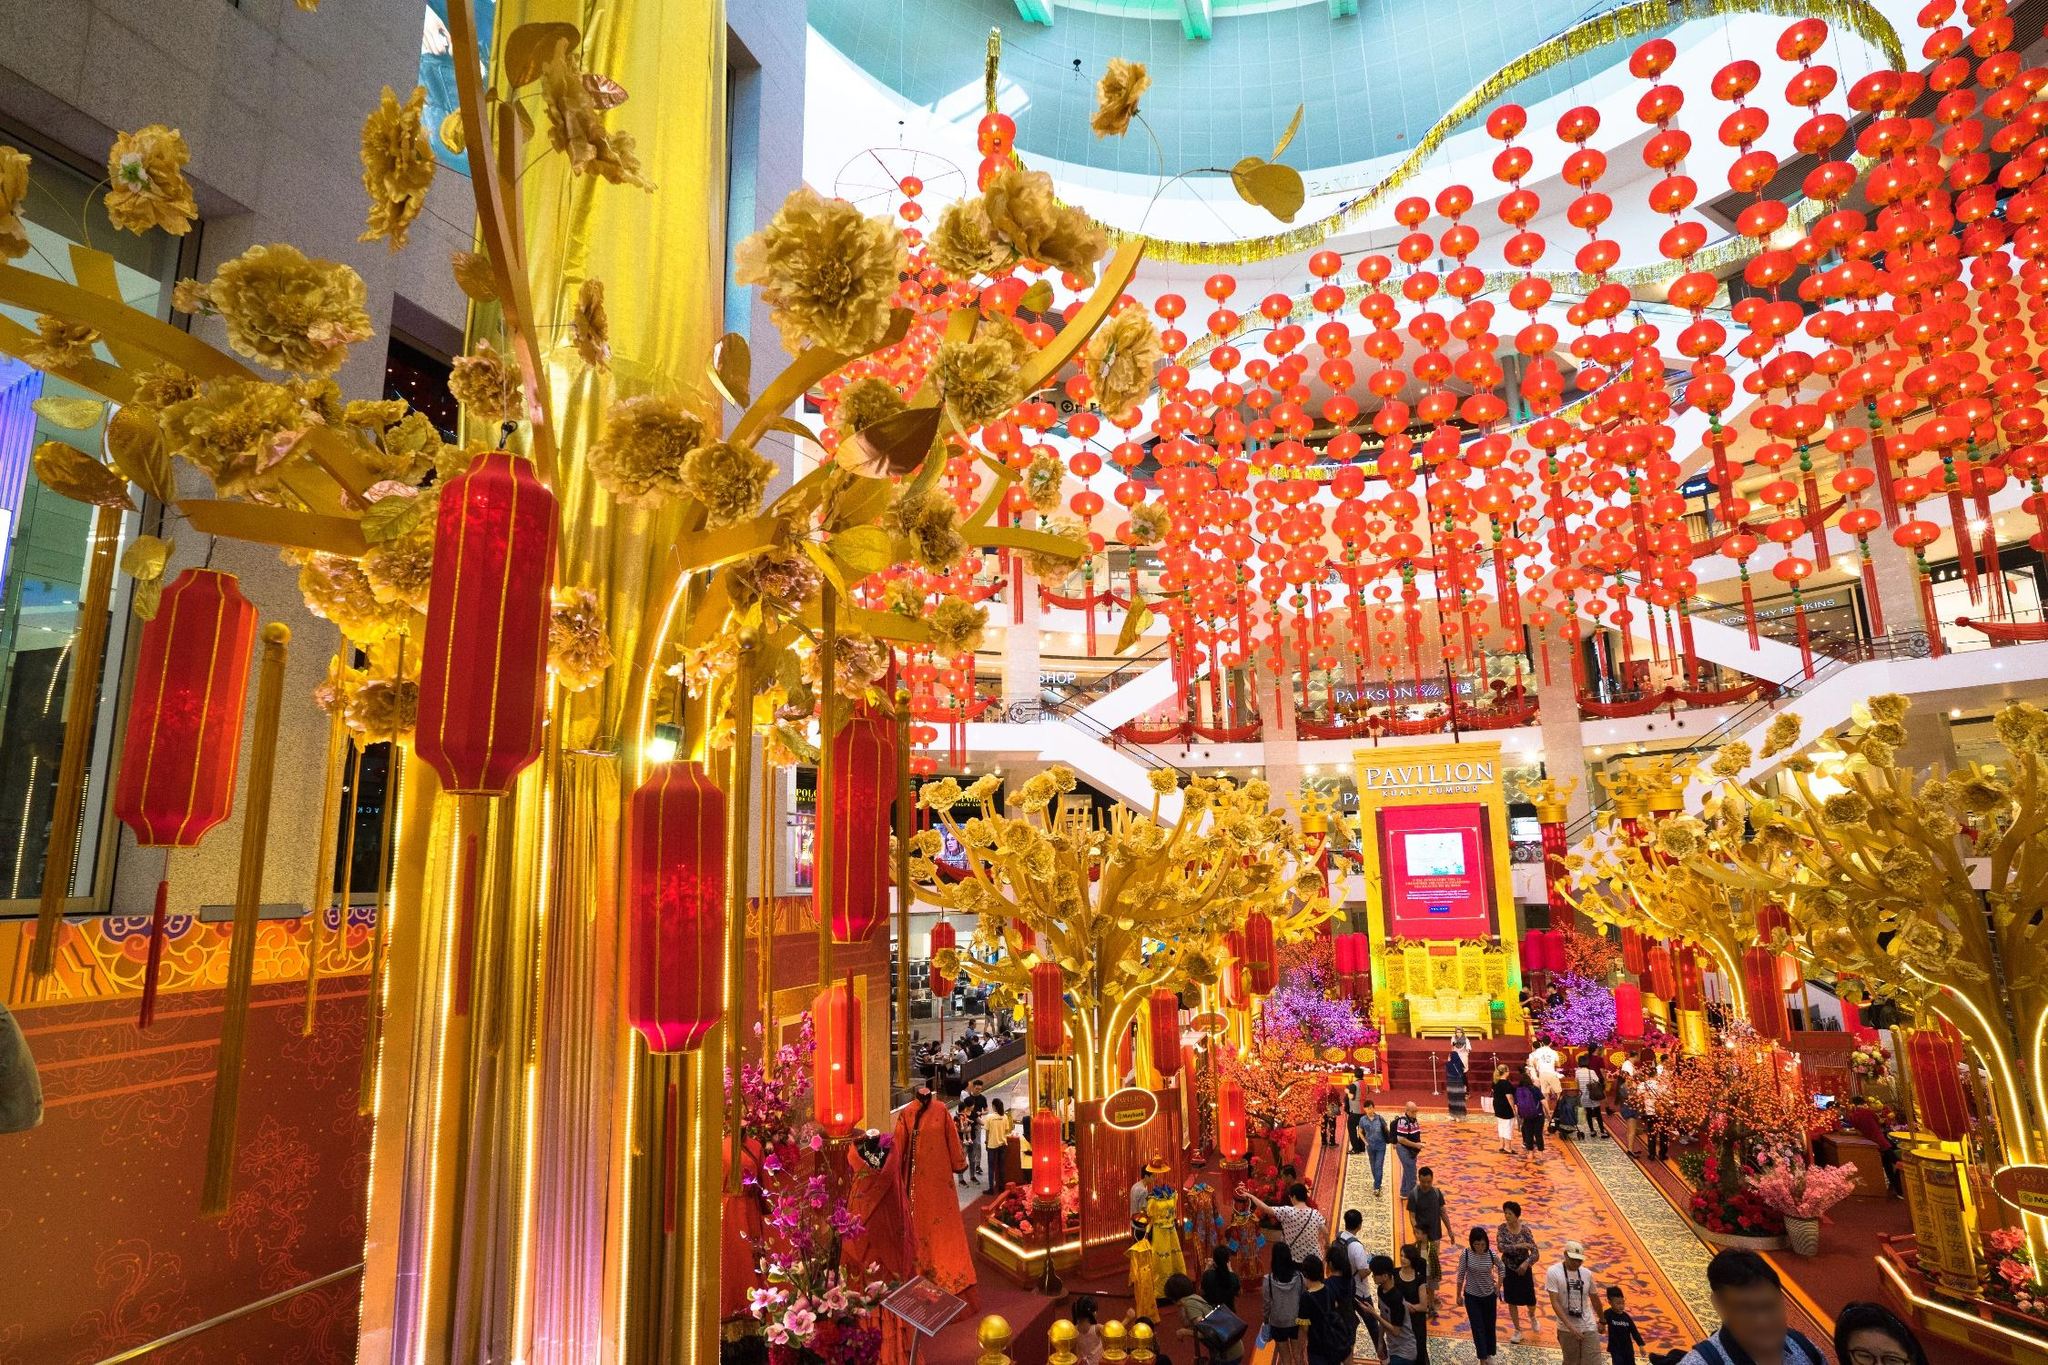Describe the following image.
 This image captures a bustling scene in a shopping mall in Kuala Lumpur, Malaysia. The mall is awash with vibrant colors, predominantly red and gold, which are traditional auspicious colors in many Asian cultures. Numerous lanterns, resplendent in these hues, are suspended from the ceiling, casting a warm glow over the scene below. Gold trees and banners add to the festive atmosphere, their metallic sheen reflecting the bright lights of the mall.

The photo offers a high-angle perspective, providing a comprehensive view of the mall's interior. From this vantage point, we can see the mall teeming with people, their figures small but distinct. They are seen walking around, engaged in shopping, their movements creating a dynamic tableau against the static backdrop of the mall's decorations.

Despite the high angle, the image doesn't reveal the specific landmark or the name of the mall. However, the reference "sa_12839" might be a code related to the image, but without additional context, it's challenging to link it to a specific worldwide landmark. The image primarily focuses on the interior of the mall and its festive decorations, rather than any identifiable exterior features of a landmark. 